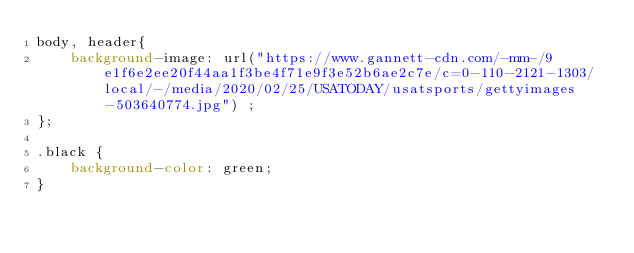Convert code to text. <code><loc_0><loc_0><loc_500><loc_500><_CSS_>body, header{
    background-image: url("https://www.gannett-cdn.com/-mm-/9e1f6e2ee20f44aa1f3be4f71e9f3e52b6ae2c7e/c=0-110-2121-1303/local/-/media/2020/02/25/USATODAY/usatsports/gettyimages-503640774.jpg") ;
};

.black {
    background-color: green;
}</code> 